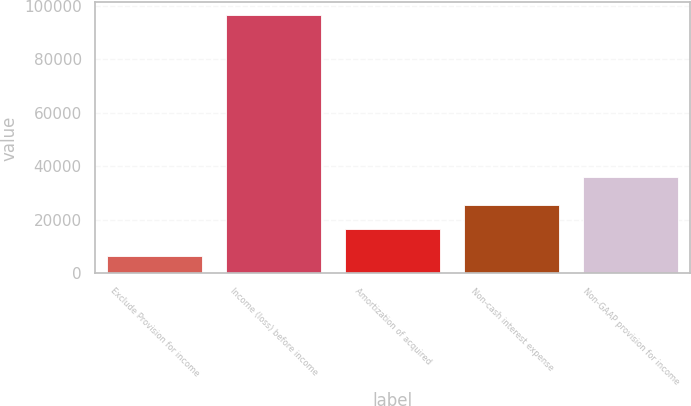<chart> <loc_0><loc_0><loc_500><loc_500><bar_chart><fcel>Exclude Provision for income<fcel>Income (loss) before income<fcel>Amortization of acquired<fcel>Non-cash interest expense<fcel>Non-GAAP provision for income<nl><fcel>6562<fcel>96309<fcel>16572<fcel>25546.7<fcel>36053<nl></chart> 